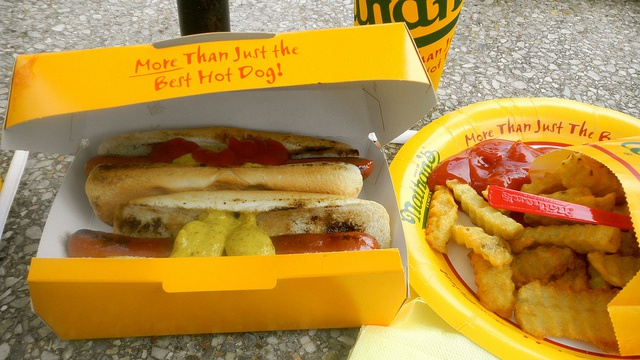Describe the objects in this image and their specific colors. I can see dining table in orange, olive, darkgray, gold, and gray tones, hot dog in darkgray, olive, maroon, and tan tones, hot dog in darkgray, maroon, olive, and tan tones, and cup in darkgray, orange, darkgreen, and olive tones in this image. 